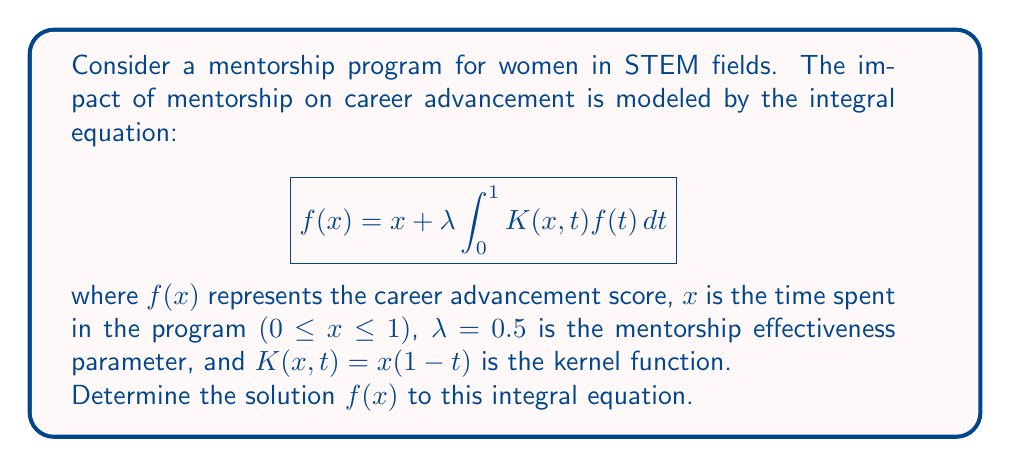Teach me how to tackle this problem. To solve this integral equation, we'll use the method of successive approximations:

1) Start with the initial approximation $f_0(x) = x$.

2) Substitute this into the right-hand side of the equation to get the next approximation:

   $$f_1(x) = x + 0.5 \int_0^1 x(1-t)t dt$$

3) Evaluate the integral:
   
   $$\int_0^1 x(1-t)t dt = x \int_0^1 (t-t^2) dt = x [\frac{t^2}{2} - \frac{t^3}{3}]_0^1 = x (\frac{1}{2} - \frac{1}{3}) = \frac{x}{6}$$

4) Therefore, $f_1(x) = x + 0.5 \cdot \frac{x}{6} = x + \frac{x}{12} = \frac{13x}{12}$

5) For the next approximation:

   $$f_2(x) = x + 0.5 \int_0^1 x(1-t)\frac{13t}{12} dt$$

6) Evaluate this integral:
   
   $$\int_0^1 x(1-t)\frac{13t}{12} dt = \frac{13x}{12} \int_0^1 (t-t^2) dt = \frac{13x}{12} \cdot \frac{1}{6} = \frac{13x}{72}$$

7) Therefore, $f_2(x) = x + 0.5 \cdot \frac{13x}{72} = x + \frac{13x}{144} = \frac{157x}{144}$

8) We can see a pattern forming. The general solution will be of the form $f(x) = cx$, where $c$ is a constant.

9) Substitute this general form into the original equation:

   $$cx = x + 0.5 \int_0^1 x(1-t)ct dt$$

10) Solve for $c$:
    
    $$cx = x + 0.5cx \int_0^1 (t-t^2) dt = x + 0.5cx \cdot \frac{1}{6} = x + \frac{cx}{12}$$
    
    $$cx - \frac{cx}{12} = x$$
    
    $$\frac{11cx}{12} = x$$
    
    $$c = \frac{12}{11}$$

Therefore, the solution is $f(x) = \frac{12x}{11}$.
Answer: $f(x) = \frac{12x}{11}$ 